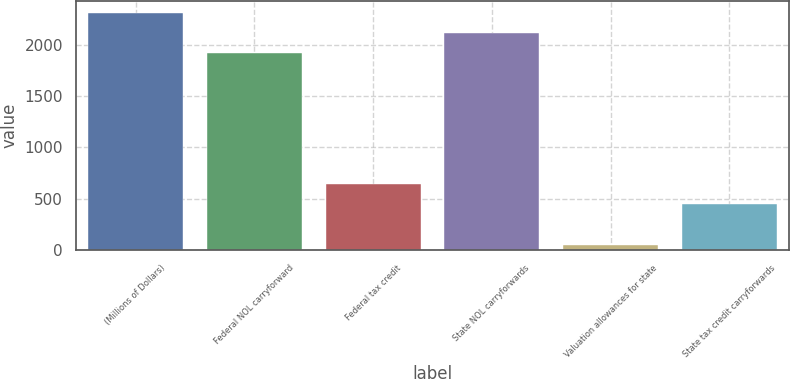Convert chart. <chart><loc_0><loc_0><loc_500><loc_500><bar_chart><fcel>(Millions of Dollars)<fcel>Federal NOL carryforward<fcel>Federal tax credit<fcel>State NOL carryforwards<fcel>Valuation allowances for state<fcel>State tax credit carryforwards<nl><fcel>2308.4<fcel>1916<fcel>642.6<fcel>2112.2<fcel>54<fcel>446.4<nl></chart> 